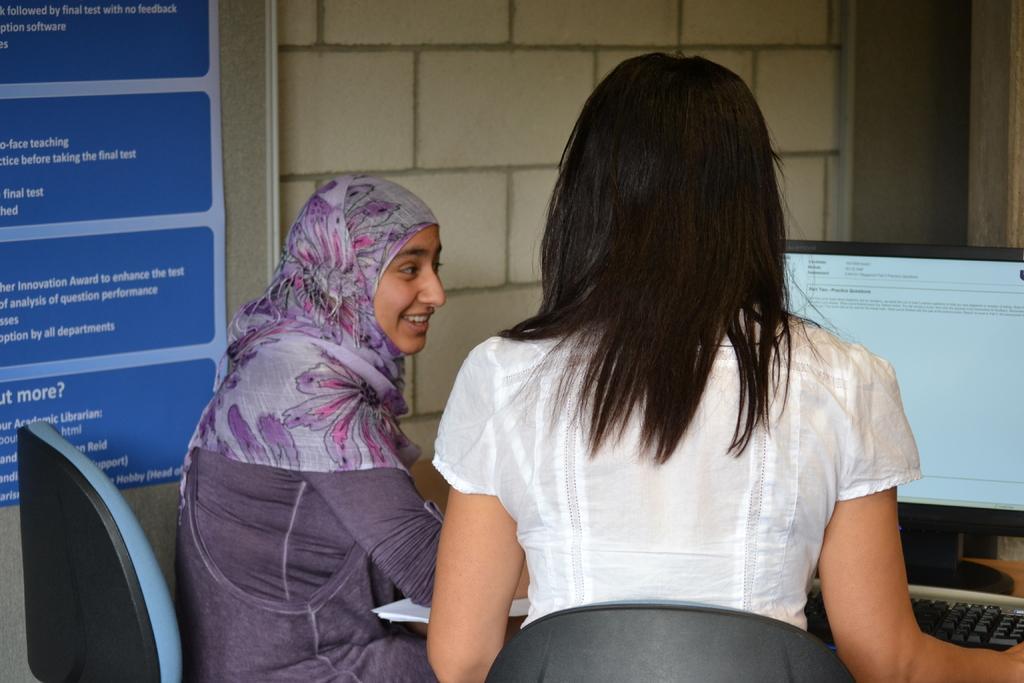Please provide a concise description of this image. In this picture I can see two women are sitting on the chairs in front of the table, on which we can see a system and some papers, side we can see a board to the wall. 